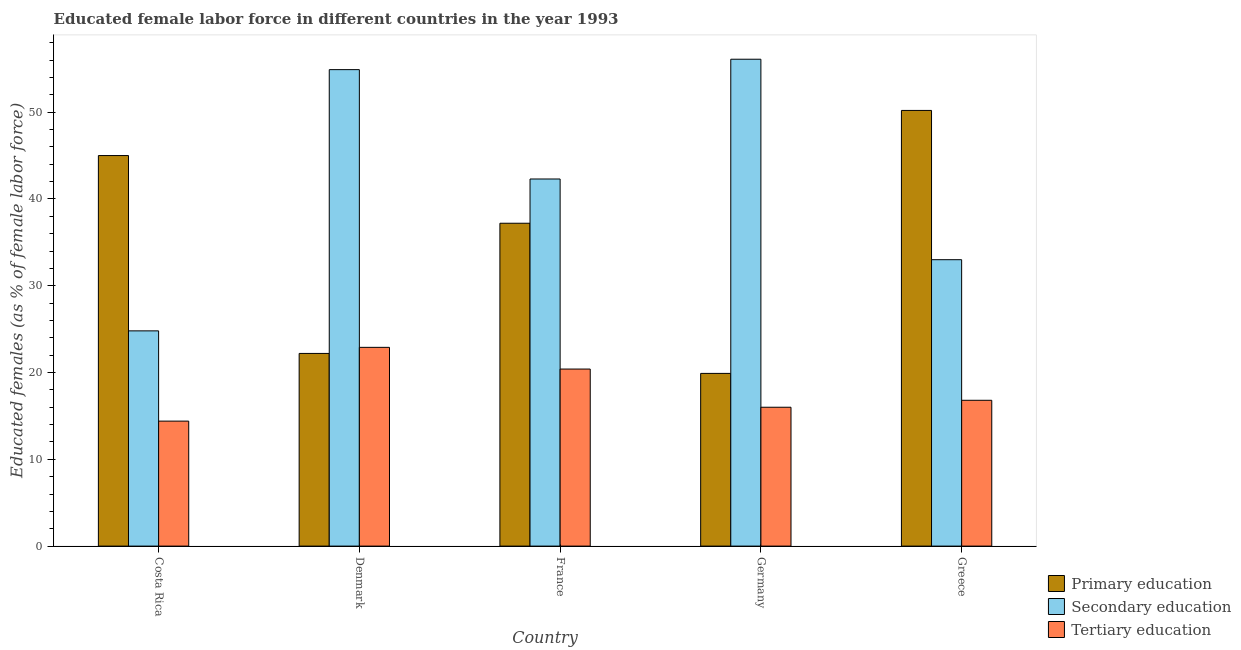How many groups of bars are there?
Your answer should be very brief. 5. What is the label of the 4th group of bars from the left?
Your answer should be compact. Germany. What is the percentage of female labor force who received primary education in Greece?
Your answer should be compact. 50.2. Across all countries, what is the maximum percentage of female labor force who received tertiary education?
Keep it short and to the point. 22.9. Across all countries, what is the minimum percentage of female labor force who received tertiary education?
Your answer should be very brief. 14.4. In which country was the percentage of female labor force who received secondary education minimum?
Provide a succinct answer. Costa Rica. What is the total percentage of female labor force who received primary education in the graph?
Your answer should be compact. 174.5. What is the difference between the percentage of female labor force who received tertiary education in Denmark and that in Greece?
Ensure brevity in your answer.  6.1. What is the difference between the percentage of female labor force who received tertiary education in Denmark and the percentage of female labor force who received primary education in Greece?
Provide a succinct answer. -27.3. What is the average percentage of female labor force who received secondary education per country?
Provide a succinct answer. 42.22. What is the difference between the percentage of female labor force who received tertiary education and percentage of female labor force who received secondary education in Costa Rica?
Make the answer very short. -10.4. In how many countries, is the percentage of female labor force who received secondary education greater than 2 %?
Your answer should be compact. 5. What is the ratio of the percentage of female labor force who received secondary education in Denmark to that in France?
Give a very brief answer. 1.3. Is the percentage of female labor force who received tertiary education in Germany less than that in Greece?
Provide a succinct answer. Yes. What is the difference between the highest and the second highest percentage of female labor force who received secondary education?
Offer a very short reply. 1.2. What is the difference between the highest and the lowest percentage of female labor force who received tertiary education?
Give a very brief answer. 8.5. In how many countries, is the percentage of female labor force who received primary education greater than the average percentage of female labor force who received primary education taken over all countries?
Provide a succinct answer. 3. What does the 2nd bar from the left in Germany represents?
Your response must be concise. Secondary education. What does the 1st bar from the right in Germany represents?
Ensure brevity in your answer.  Tertiary education. How many bars are there?
Make the answer very short. 15. Are all the bars in the graph horizontal?
Provide a short and direct response. No. What is the difference between two consecutive major ticks on the Y-axis?
Make the answer very short. 10. Are the values on the major ticks of Y-axis written in scientific E-notation?
Your answer should be very brief. No. Where does the legend appear in the graph?
Ensure brevity in your answer.  Bottom right. How are the legend labels stacked?
Your answer should be very brief. Vertical. What is the title of the graph?
Make the answer very short. Educated female labor force in different countries in the year 1993. Does "Interest" appear as one of the legend labels in the graph?
Your answer should be very brief. No. What is the label or title of the Y-axis?
Your response must be concise. Educated females (as % of female labor force). What is the Educated females (as % of female labor force) of Secondary education in Costa Rica?
Your answer should be compact. 24.8. What is the Educated females (as % of female labor force) of Tertiary education in Costa Rica?
Your answer should be compact. 14.4. What is the Educated females (as % of female labor force) in Primary education in Denmark?
Keep it short and to the point. 22.2. What is the Educated females (as % of female labor force) in Secondary education in Denmark?
Make the answer very short. 54.9. What is the Educated females (as % of female labor force) in Tertiary education in Denmark?
Ensure brevity in your answer.  22.9. What is the Educated females (as % of female labor force) in Primary education in France?
Provide a short and direct response. 37.2. What is the Educated females (as % of female labor force) in Secondary education in France?
Keep it short and to the point. 42.3. What is the Educated females (as % of female labor force) in Tertiary education in France?
Give a very brief answer. 20.4. What is the Educated females (as % of female labor force) of Primary education in Germany?
Offer a terse response. 19.9. What is the Educated females (as % of female labor force) of Secondary education in Germany?
Provide a succinct answer. 56.1. What is the Educated females (as % of female labor force) in Tertiary education in Germany?
Provide a short and direct response. 16. What is the Educated females (as % of female labor force) of Primary education in Greece?
Ensure brevity in your answer.  50.2. What is the Educated females (as % of female labor force) in Secondary education in Greece?
Ensure brevity in your answer.  33. What is the Educated females (as % of female labor force) of Tertiary education in Greece?
Your answer should be very brief. 16.8. Across all countries, what is the maximum Educated females (as % of female labor force) of Primary education?
Keep it short and to the point. 50.2. Across all countries, what is the maximum Educated females (as % of female labor force) of Secondary education?
Offer a very short reply. 56.1. Across all countries, what is the maximum Educated females (as % of female labor force) of Tertiary education?
Make the answer very short. 22.9. Across all countries, what is the minimum Educated females (as % of female labor force) in Primary education?
Offer a terse response. 19.9. Across all countries, what is the minimum Educated females (as % of female labor force) in Secondary education?
Your answer should be very brief. 24.8. Across all countries, what is the minimum Educated females (as % of female labor force) in Tertiary education?
Offer a very short reply. 14.4. What is the total Educated females (as % of female labor force) in Primary education in the graph?
Provide a short and direct response. 174.5. What is the total Educated females (as % of female labor force) in Secondary education in the graph?
Give a very brief answer. 211.1. What is the total Educated females (as % of female labor force) in Tertiary education in the graph?
Give a very brief answer. 90.5. What is the difference between the Educated females (as % of female labor force) in Primary education in Costa Rica and that in Denmark?
Keep it short and to the point. 22.8. What is the difference between the Educated females (as % of female labor force) of Secondary education in Costa Rica and that in Denmark?
Provide a short and direct response. -30.1. What is the difference between the Educated females (as % of female labor force) of Tertiary education in Costa Rica and that in Denmark?
Offer a very short reply. -8.5. What is the difference between the Educated females (as % of female labor force) in Primary education in Costa Rica and that in France?
Offer a very short reply. 7.8. What is the difference between the Educated females (as % of female labor force) of Secondary education in Costa Rica and that in France?
Make the answer very short. -17.5. What is the difference between the Educated females (as % of female labor force) in Tertiary education in Costa Rica and that in France?
Offer a very short reply. -6. What is the difference between the Educated females (as % of female labor force) of Primary education in Costa Rica and that in Germany?
Your answer should be compact. 25.1. What is the difference between the Educated females (as % of female labor force) of Secondary education in Costa Rica and that in Germany?
Give a very brief answer. -31.3. What is the difference between the Educated females (as % of female labor force) in Primary education in Denmark and that in France?
Provide a short and direct response. -15. What is the difference between the Educated females (as % of female labor force) in Tertiary education in Denmark and that in Germany?
Your answer should be very brief. 6.9. What is the difference between the Educated females (as % of female labor force) of Primary education in Denmark and that in Greece?
Offer a terse response. -28. What is the difference between the Educated females (as % of female labor force) in Secondary education in Denmark and that in Greece?
Make the answer very short. 21.9. What is the difference between the Educated females (as % of female labor force) of Tertiary education in France and that in Germany?
Offer a very short reply. 4.4. What is the difference between the Educated females (as % of female labor force) of Primary education in France and that in Greece?
Provide a succinct answer. -13. What is the difference between the Educated females (as % of female labor force) of Secondary education in France and that in Greece?
Make the answer very short. 9.3. What is the difference between the Educated females (as % of female labor force) in Tertiary education in France and that in Greece?
Make the answer very short. 3.6. What is the difference between the Educated females (as % of female labor force) in Primary education in Germany and that in Greece?
Give a very brief answer. -30.3. What is the difference between the Educated females (as % of female labor force) of Secondary education in Germany and that in Greece?
Provide a succinct answer. 23.1. What is the difference between the Educated females (as % of female labor force) in Tertiary education in Germany and that in Greece?
Your response must be concise. -0.8. What is the difference between the Educated females (as % of female labor force) in Primary education in Costa Rica and the Educated females (as % of female labor force) in Secondary education in Denmark?
Offer a terse response. -9.9. What is the difference between the Educated females (as % of female labor force) in Primary education in Costa Rica and the Educated females (as % of female labor force) in Tertiary education in Denmark?
Offer a very short reply. 22.1. What is the difference between the Educated females (as % of female labor force) of Secondary education in Costa Rica and the Educated females (as % of female labor force) of Tertiary education in Denmark?
Provide a succinct answer. 1.9. What is the difference between the Educated females (as % of female labor force) of Primary education in Costa Rica and the Educated females (as % of female labor force) of Tertiary education in France?
Provide a succinct answer. 24.6. What is the difference between the Educated females (as % of female labor force) of Primary education in Costa Rica and the Educated females (as % of female labor force) of Tertiary education in Germany?
Your answer should be compact. 29. What is the difference between the Educated females (as % of female labor force) in Secondary education in Costa Rica and the Educated females (as % of female labor force) in Tertiary education in Germany?
Offer a terse response. 8.8. What is the difference between the Educated females (as % of female labor force) of Primary education in Costa Rica and the Educated females (as % of female labor force) of Secondary education in Greece?
Keep it short and to the point. 12. What is the difference between the Educated females (as % of female labor force) in Primary education in Costa Rica and the Educated females (as % of female labor force) in Tertiary education in Greece?
Your answer should be very brief. 28.2. What is the difference between the Educated females (as % of female labor force) in Secondary education in Costa Rica and the Educated females (as % of female labor force) in Tertiary education in Greece?
Keep it short and to the point. 8. What is the difference between the Educated females (as % of female labor force) of Primary education in Denmark and the Educated females (as % of female labor force) of Secondary education in France?
Offer a terse response. -20.1. What is the difference between the Educated females (as % of female labor force) of Secondary education in Denmark and the Educated females (as % of female labor force) of Tertiary education in France?
Provide a short and direct response. 34.5. What is the difference between the Educated females (as % of female labor force) of Primary education in Denmark and the Educated females (as % of female labor force) of Secondary education in Germany?
Keep it short and to the point. -33.9. What is the difference between the Educated females (as % of female labor force) in Primary education in Denmark and the Educated females (as % of female labor force) in Tertiary education in Germany?
Offer a terse response. 6.2. What is the difference between the Educated females (as % of female labor force) in Secondary education in Denmark and the Educated females (as % of female labor force) in Tertiary education in Germany?
Give a very brief answer. 38.9. What is the difference between the Educated females (as % of female labor force) of Secondary education in Denmark and the Educated females (as % of female labor force) of Tertiary education in Greece?
Your answer should be compact. 38.1. What is the difference between the Educated females (as % of female labor force) of Primary education in France and the Educated females (as % of female labor force) of Secondary education in Germany?
Provide a succinct answer. -18.9. What is the difference between the Educated females (as % of female labor force) of Primary education in France and the Educated females (as % of female labor force) of Tertiary education in Germany?
Provide a succinct answer. 21.2. What is the difference between the Educated females (as % of female labor force) in Secondary education in France and the Educated females (as % of female labor force) in Tertiary education in Germany?
Your answer should be very brief. 26.3. What is the difference between the Educated females (as % of female labor force) in Primary education in France and the Educated females (as % of female labor force) in Tertiary education in Greece?
Provide a short and direct response. 20.4. What is the difference between the Educated females (as % of female labor force) in Primary education in Germany and the Educated females (as % of female labor force) in Tertiary education in Greece?
Offer a terse response. 3.1. What is the difference between the Educated females (as % of female labor force) of Secondary education in Germany and the Educated females (as % of female labor force) of Tertiary education in Greece?
Give a very brief answer. 39.3. What is the average Educated females (as % of female labor force) in Primary education per country?
Offer a terse response. 34.9. What is the average Educated females (as % of female labor force) in Secondary education per country?
Offer a terse response. 42.22. What is the difference between the Educated females (as % of female labor force) in Primary education and Educated females (as % of female labor force) in Secondary education in Costa Rica?
Provide a short and direct response. 20.2. What is the difference between the Educated females (as % of female labor force) of Primary education and Educated females (as % of female labor force) of Tertiary education in Costa Rica?
Make the answer very short. 30.6. What is the difference between the Educated females (as % of female labor force) in Secondary education and Educated females (as % of female labor force) in Tertiary education in Costa Rica?
Offer a terse response. 10.4. What is the difference between the Educated females (as % of female labor force) in Primary education and Educated females (as % of female labor force) in Secondary education in Denmark?
Keep it short and to the point. -32.7. What is the difference between the Educated females (as % of female labor force) of Primary education and Educated females (as % of female labor force) of Tertiary education in Denmark?
Ensure brevity in your answer.  -0.7. What is the difference between the Educated females (as % of female labor force) in Secondary education and Educated females (as % of female labor force) in Tertiary education in France?
Your answer should be very brief. 21.9. What is the difference between the Educated females (as % of female labor force) in Primary education and Educated females (as % of female labor force) in Secondary education in Germany?
Keep it short and to the point. -36.2. What is the difference between the Educated females (as % of female labor force) of Primary education and Educated females (as % of female labor force) of Tertiary education in Germany?
Offer a very short reply. 3.9. What is the difference between the Educated females (as % of female labor force) in Secondary education and Educated females (as % of female labor force) in Tertiary education in Germany?
Provide a short and direct response. 40.1. What is the difference between the Educated females (as % of female labor force) in Primary education and Educated females (as % of female labor force) in Secondary education in Greece?
Give a very brief answer. 17.2. What is the difference between the Educated females (as % of female labor force) of Primary education and Educated females (as % of female labor force) of Tertiary education in Greece?
Keep it short and to the point. 33.4. What is the ratio of the Educated females (as % of female labor force) in Primary education in Costa Rica to that in Denmark?
Provide a short and direct response. 2.03. What is the ratio of the Educated females (as % of female labor force) of Secondary education in Costa Rica to that in Denmark?
Keep it short and to the point. 0.45. What is the ratio of the Educated females (as % of female labor force) in Tertiary education in Costa Rica to that in Denmark?
Ensure brevity in your answer.  0.63. What is the ratio of the Educated females (as % of female labor force) of Primary education in Costa Rica to that in France?
Offer a very short reply. 1.21. What is the ratio of the Educated females (as % of female labor force) of Secondary education in Costa Rica to that in France?
Make the answer very short. 0.59. What is the ratio of the Educated females (as % of female labor force) in Tertiary education in Costa Rica to that in France?
Provide a short and direct response. 0.71. What is the ratio of the Educated females (as % of female labor force) in Primary education in Costa Rica to that in Germany?
Provide a short and direct response. 2.26. What is the ratio of the Educated females (as % of female labor force) in Secondary education in Costa Rica to that in Germany?
Offer a very short reply. 0.44. What is the ratio of the Educated females (as % of female labor force) in Primary education in Costa Rica to that in Greece?
Offer a very short reply. 0.9. What is the ratio of the Educated females (as % of female labor force) in Secondary education in Costa Rica to that in Greece?
Your answer should be very brief. 0.75. What is the ratio of the Educated females (as % of female labor force) of Tertiary education in Costa Rica to that in Greece?
Provide a succinct answer. 0.86. What is the ratio of the Educated females (as % of female labor force) in Primary education in Denmark to that in France?
Make the answer very short. 0.6. What is the ratio of the Educated females (as % of female labor force) of Secondary education in Denmark to that in France?
Provide a short and direct response. 1.3. What is the ratio of the Educated females (as % of female labor force) in Tertiary education in Denmark to that in France?
Provide a succinct answer. 1.12. What is the ratio of the Educated females (as % of female labor force) in Primary education in Denmark to that in Germany?
Your answer should be very brief. 1.12. What is the ratio of the Educated females (as % of female labor force) in Secondary education in Denmark to that in Germany?
Ensure brevity in your answer.  0.98. What is the ratio of the Educated females (as % of female labor force) of Tertiary education in Denmark to that in Germany?
Provide a short and direct response. 1.43. What is the ratio of the Educated females (as % of female labor force) of Primary education in Denmark to that in Greece?
Make the answer very short. 0.44. What is the ratio of the Educated females (as % of female labor force) of Secondary education in Denmark to that in Greece?
Offer a terse response. 1.66. What is the ratio of the Educated females (as % of female labor force) of Tertiary education in Denmark to that in Greece?
Offer a terse response. 1.36. What is the ratio of the Educated females (as % of female labor force) in Primary education in France to that in Germany?
Give a very brief answer. 1.87. What is the ratio of the Educated females (as % of female labor force) of Secondary education in France to that in Germany?
Provide a succinct answer. 0.75. What is the ratio of the Educated females (as % of female labor force) of Tertiary education in France to that in Germany?
Your answer should be compact. 1.27. What is the ratio of the Educated females (as % of female labor force) in Primary education in France to that in Greece?
Give a very brief answer. 0.74. What is the ratio of the Educated females (as % of female labor force) in Secondary education in France to that in Greece?
Your answer should be very brief. 1.28. What is the ratio of the Educated females (as % of female labor force) of Tertiary education in France to that in Greece?
Offer a terse response. 1.21. What is the ratio of the Educated females (as % of female labor force) in Primary education in Germany to that in Greece?
Ensure brevity in your answer.  0.4. What is the difference between the highest and the second highest Educated females (as % of female labor force) of Tertiary education?
Your response must be concise. 2.5. What is the difference between the highest and the lowest Educated females (as % of female labor force) in Primary education?
Your answer should be very brief. 30.3. What is the difference between the highest and the lowest Educated females (as % of female labor force) in Secondary education?
Provide a short and direct response. 31.3. What is the difference between the highest and the lowest Educated females (as % of female labor force) of Tertiary education?
Ensure brevity in your answer.  8.5. 